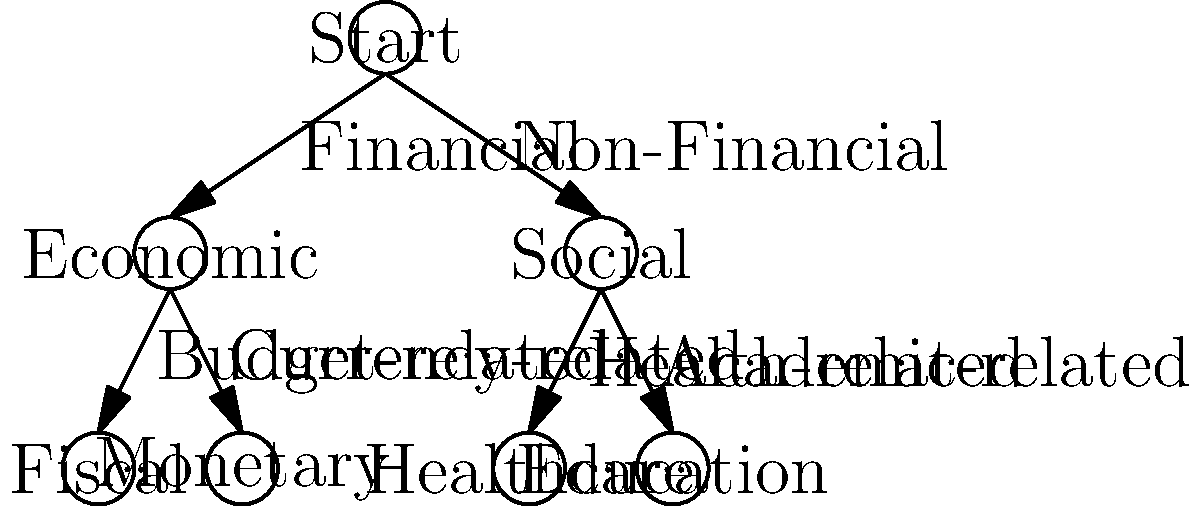As a parliamentarian, you are tasked with implementing a decision tree to classify bill proposals. Based on the decision tree diagram provided, what category would a bill proposal concerning university funding fall under? To determine the category for a bill proposal concerning university funding, we need to follow the decision tree from top to bottom:

1. Start at the root node "Start".

2. The first decision is between "Financial" and "Non-Financial":
   - University funding is related to finances, so we follow the "Financial" branch.

3. This leads us to the "Economic" node, where we have two options: "Budget-related" and "Currency-related":
   - University funding is not directly related to currency, so we don't choose the "Monetary" category.
   - However, it is related to budgeting and allocation of funds, so we follow the "Budget-related" branch.

4. This brings us to the "Fiscal" category, which is our final classification.

Although education is mentioned in the tree, it falls under the "Non-Financial" branch, which we did not follow. The question specifically asks about university funding, which is a fiscal matter related to budgeting and economic policy.
Answer: Fiscal 